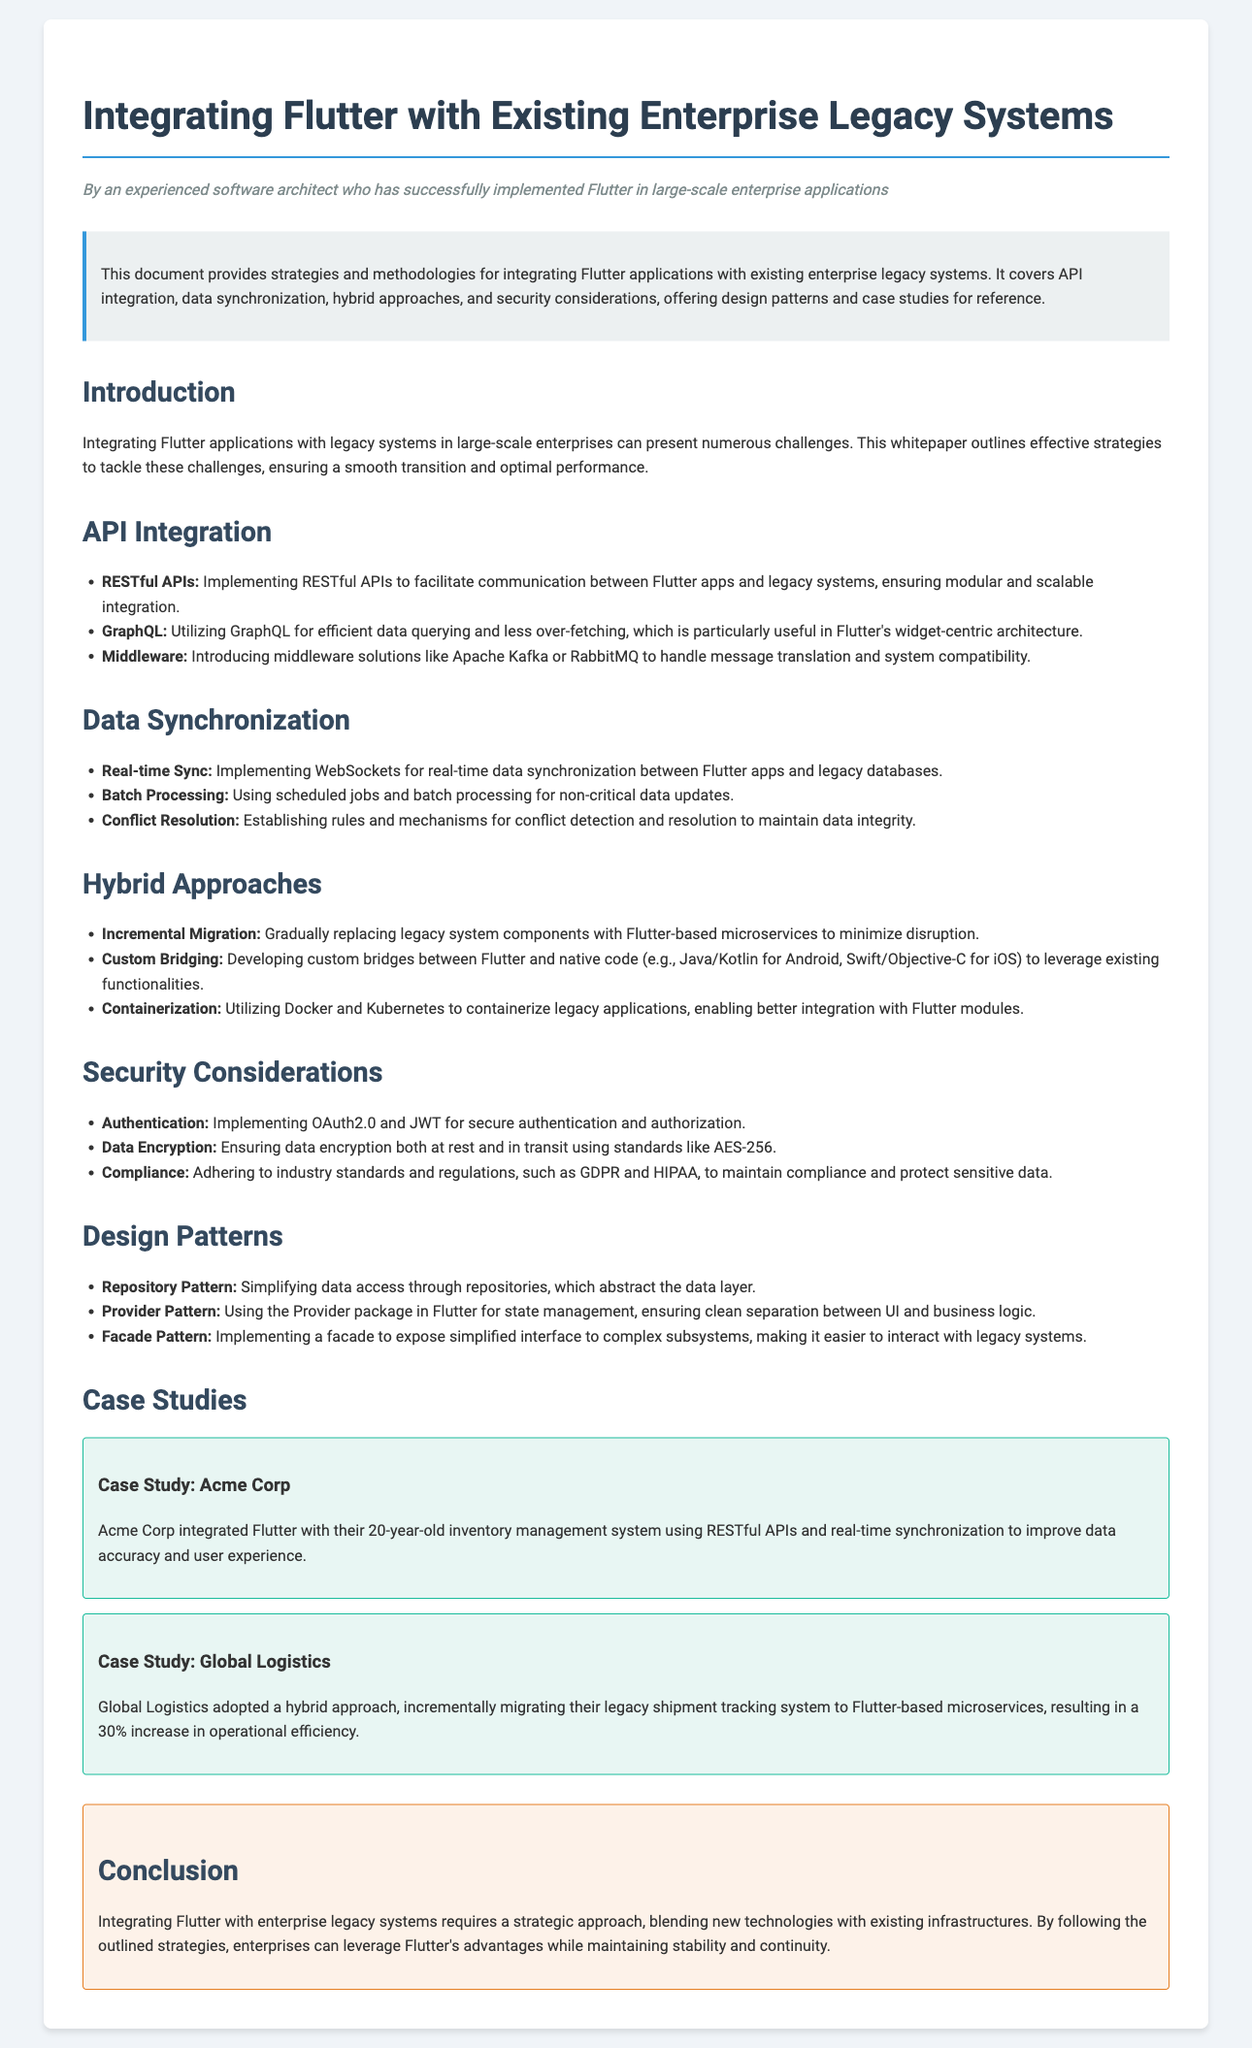What does this document focus on? The document outlines strategies and methodologies for integrating Flutter applications with existing enterprise legacy systems.
Answer: Integrating Flutter applications with existing enterprise legacy systems What are the benefits of using RESTful APIs according to the document? It facilitates communication between Flutter apps and legacy systems, ensuring modular and scalable integration.
Answer: Modular and scalable integration Which real-time synchronization technology is mentioned? The document discusses implementing WebSockets for real-time data synchronization.
Answer: WebSockets What is one of the case studies mentioned? The case study of Acme Corp highlights their integration of Flutter with a 20-year-old inventory management system.
Answer: Acme Corp What security standard is recommended for data encryption? The document emphasizes using AES-256 for data encryption both at rest and in transit.
Answer: AES-256 What is the hybrid approach involving gradual migration called? The document mentions Incremental Migration as the gradual approach to replacing legacy systems.
Answer: Incremental Migration Which design pattern simplifies data access? The Repository Pattern is highlighted as a means to simplify data access through repositories.
Answer: Repository Pattern How much did Global Logistics improve their operational efficiency? The integration led to a reported 30% increase in operational efficiency for Global Logistics.
Answer: 30% 